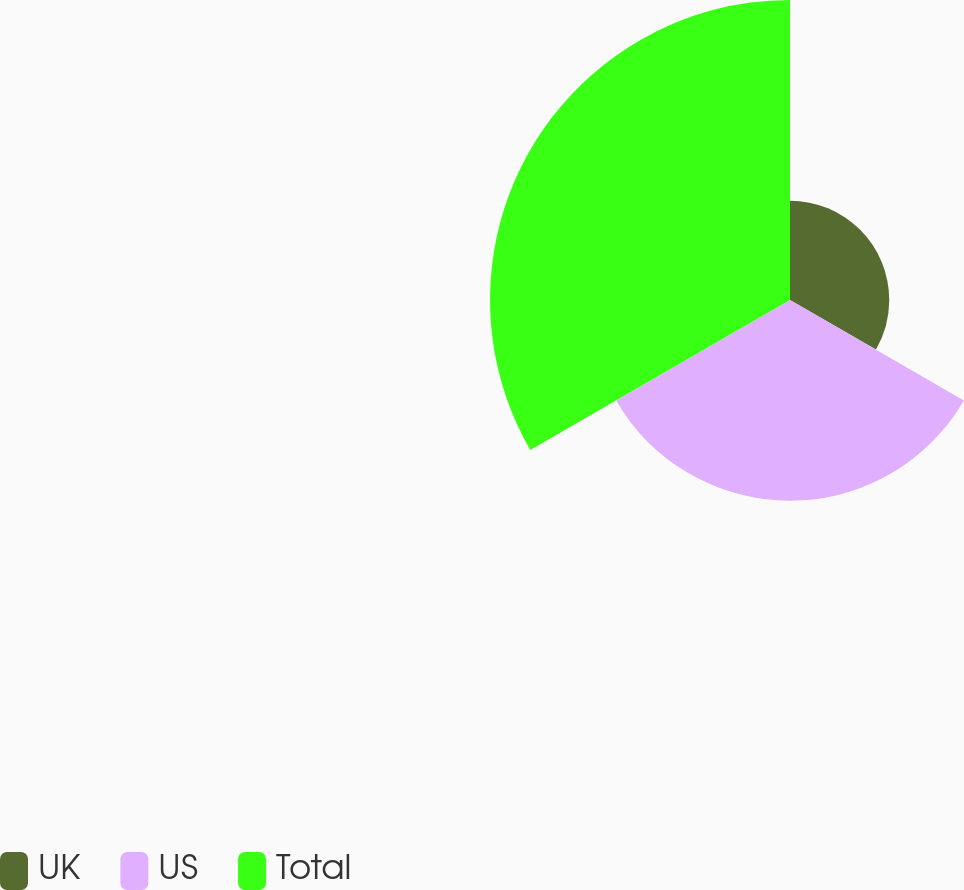Convert chart. <chart><loc_0><loc_0><loc_500><loc_500><pie_chart><fcel>UK<fcel>US<fcel>Total<nl><fcel>16.54%<fcel>33.46%<fcel>50.0%<nl></chart> 